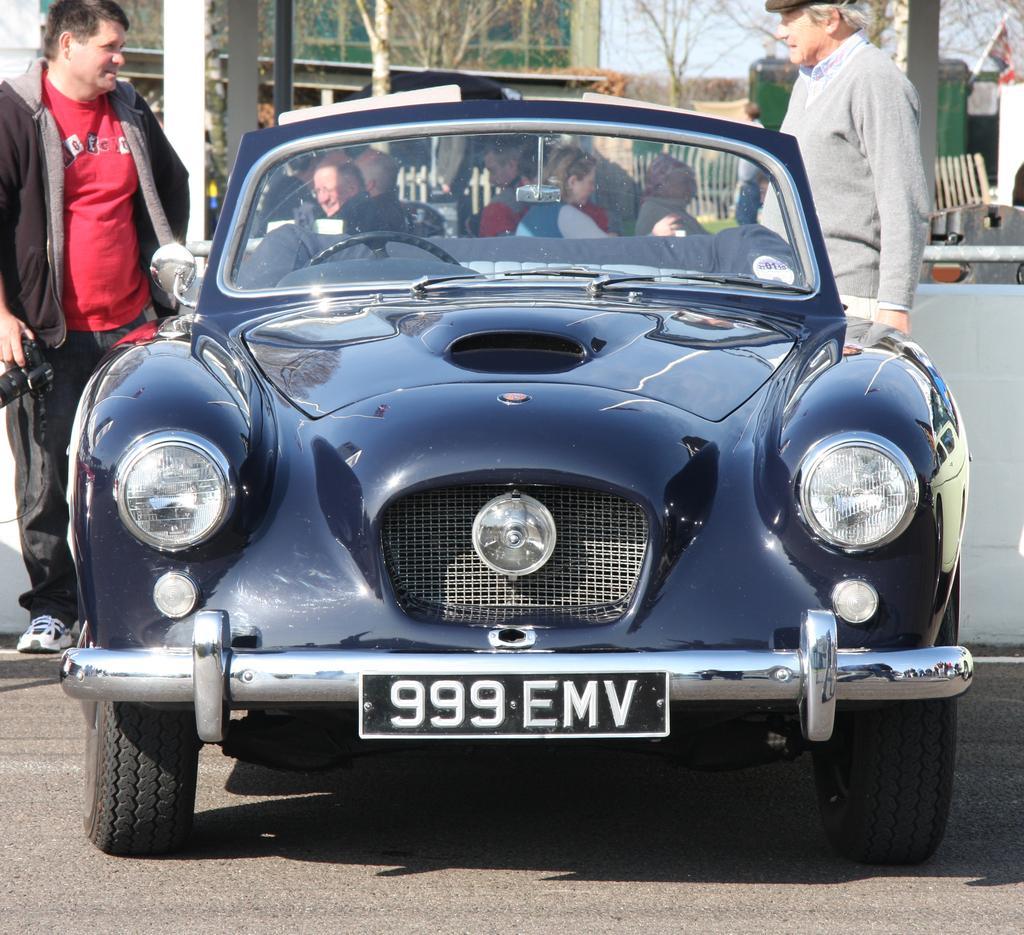Could you give a brief overview of what you see in this image? This picture is taken on a road. There is a car at the center of the image and people are sitting in it. There are two men standing on either sides of the car. The man to the left corner is holding a camera in his hand. In the background there is building, tree, sky and railing. 